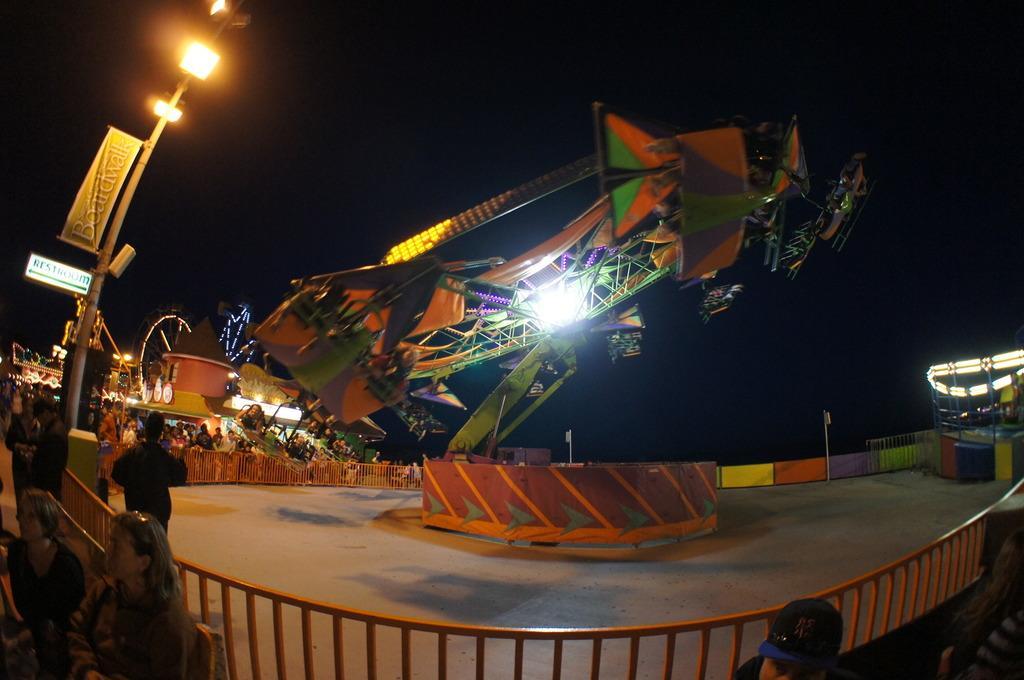Please provide a concise description of this image. In this image, we can see a fun ride. There are some persons in the bottom left of the image wearing clothes. There is a pole on the left side of the image. 